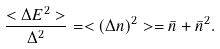Convert formula to latex. <formula><loc_0><loc_0><loc_500><loc_500>\frac { < \Delta E ^ { 2 } > } { \Delta ^ { 2 } } = < ( \Delta n ) ^ { 2 } > = \bar { n } + \bar { n } ^ { 2 } .</formula> 